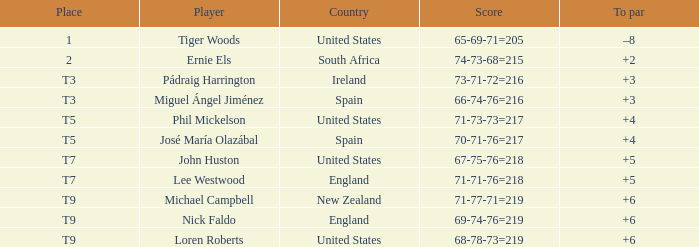What is Score, when Country is "United States", and when To Par is "+4"? 71-73-73=217. 